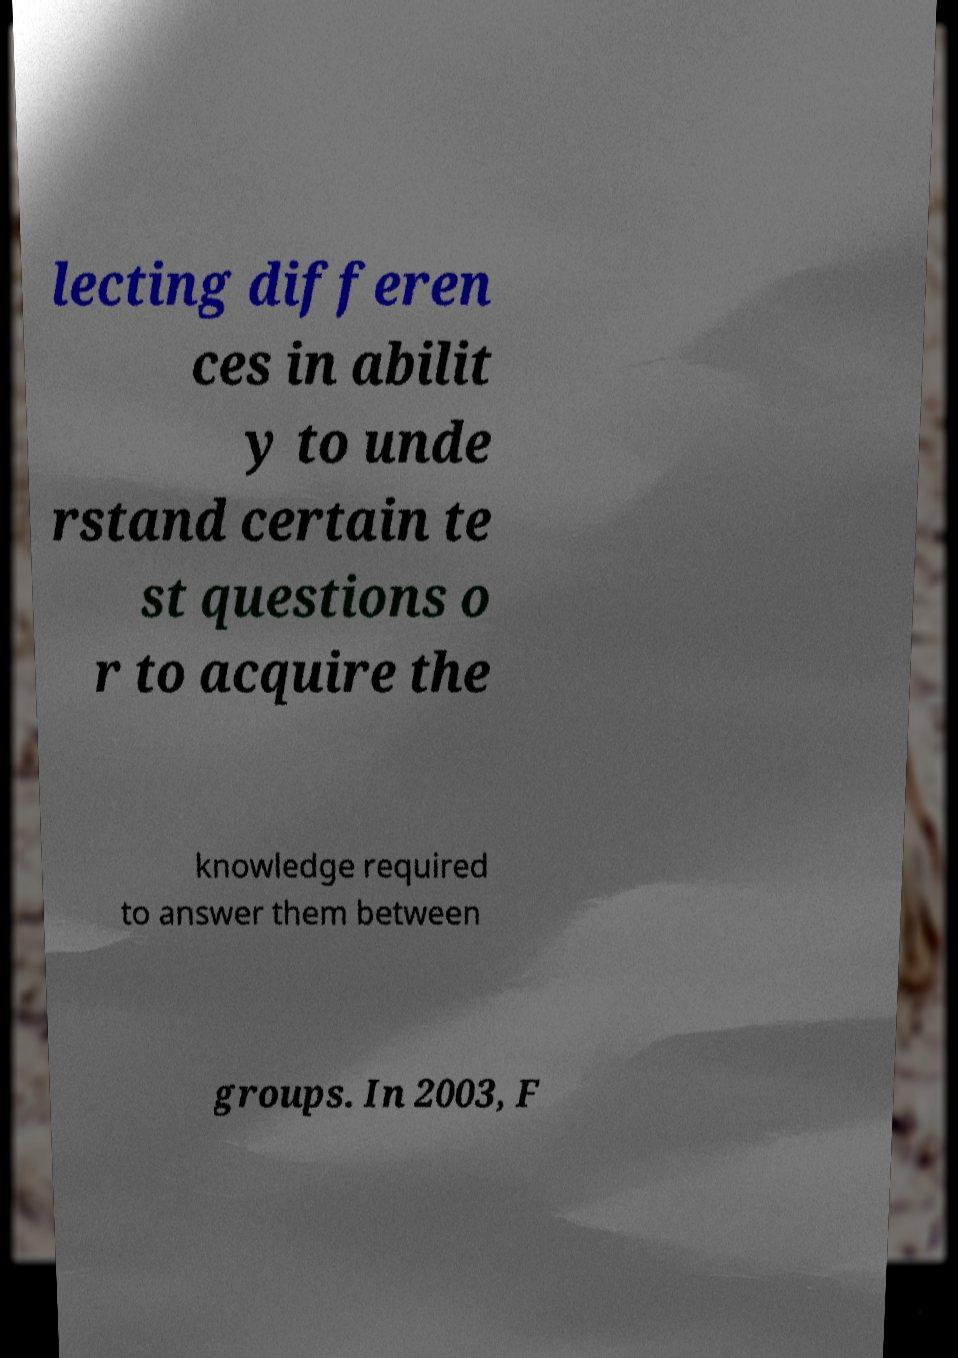Could you extract and type out the text from this image? lecting differen ces in abilit y to unde rstand certain te st questions o r to acquire the knowledge required to answer them between groups. In 2003, F 